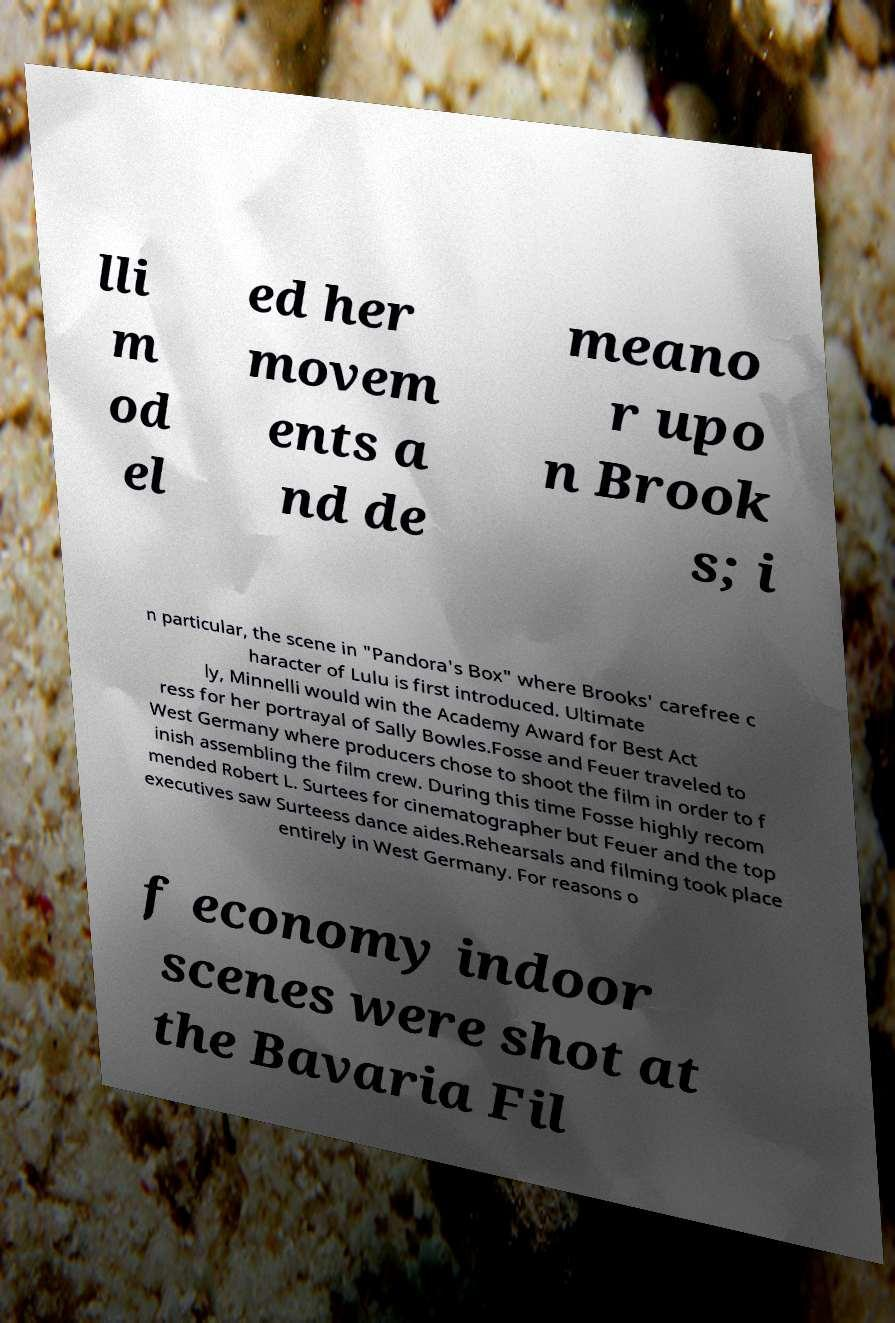For documentation purposes, I need the text within this image transcribed. Could you provide that? lli m od el ed her movem ents a nd de meano r upo n Brook s; i n particular, the scene in "Pandora's Box" where Brooks' carefree c haracter of Lulu is first introduced. Ultimate ly, Minnelli would win the Academy Award for Best Act ress for her portrayal of Sally Bowles.Fosse and Feuer traveled to West Germany where producers chose to shoot the film in order to f inish assembling the film crew. During this time Fosse highly recom mended Robert L. Surtees for cinematographer but Feuer and the top executives saw Surteess dance aides.Rehearsals and filming took place entirely in West Germany. For reasons o f economy indoor scenes were shot at the Bavaria Fil 